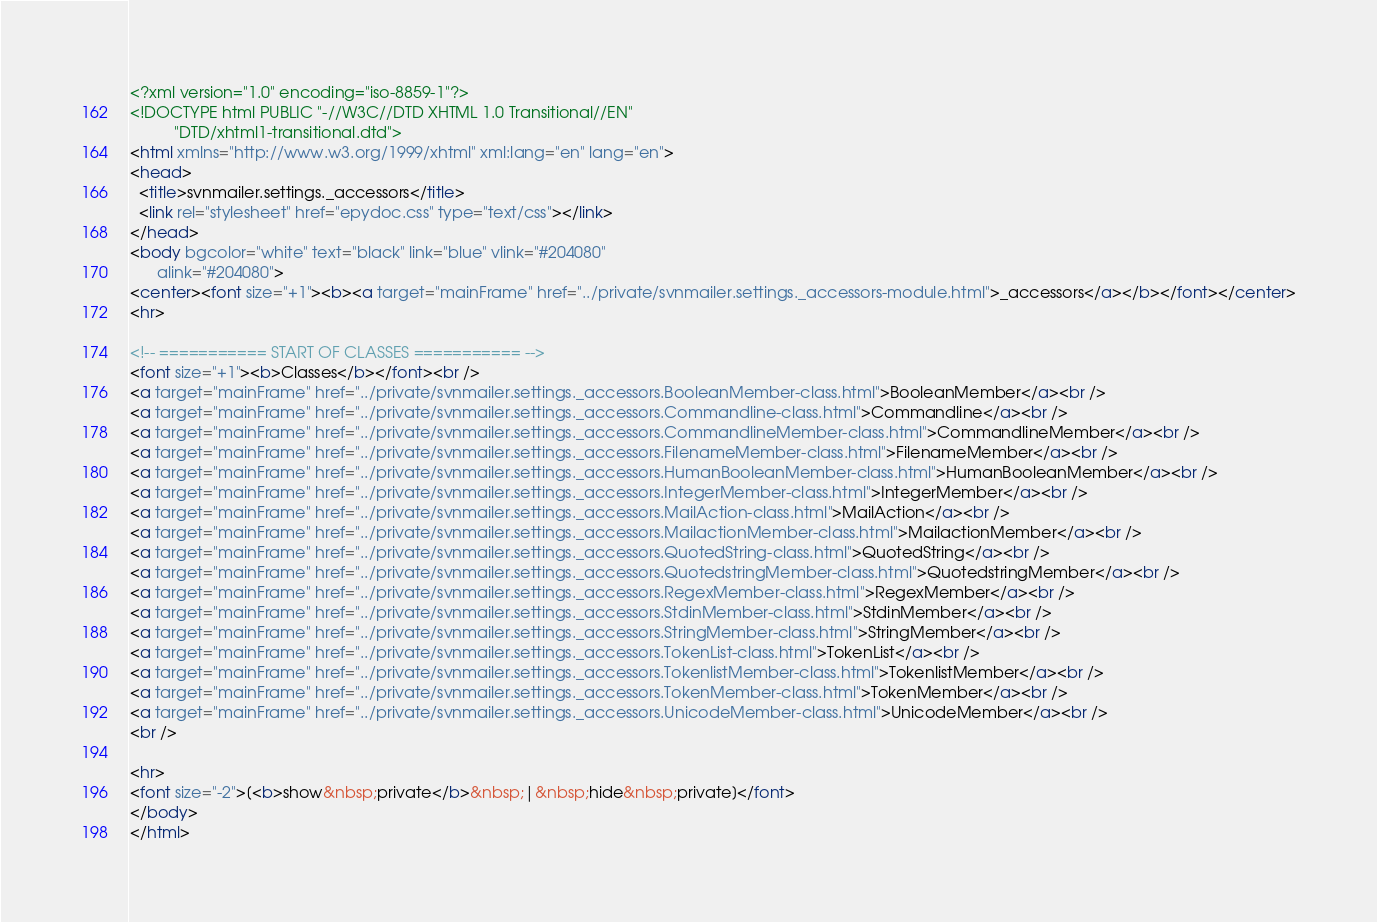Convert code to text. <code><loc_0><loc_0><loc_500><loc_500><_HTML_><?xml version="1.0" encoding="iso-8859-1"?>
<!DOCTYPE html PUBLIC "-//W3C//DTD XHTML 1.0 Transitional//EN"
          "DTD/xhtml1-transitional.dtd">
<html xmlns="http://www.w3.org/1999/xhtml" xml:lang="en" lang="en">
<head>
  <title>svnmailer.settings._accessors</title>
  <link rel="stylesheet" href="epydoc.css" type="text/css"></link>
</head>
<body bgcolor="white" text="black" link="blue" vlink="#204080"
      alink="#204080">
<center><font size="+1"><b><a target="mainFrame" href="../private/svnmailer.settings._accessors-module.html">_accessors</a></b></font></center>
<hr>

<!-- =========== START OF CLASSES =========== -->
<font size="+1"><b>Classes</b></font><br />
<a target="mainFrame" href="../private/svnmailer.settings._accessors.BooleanMember-class.html">BooleanMember</a><br />
<a target="mainFrame" href="../private/svnmailer.settings._accessors.Commandline-class.html">Commandline</a><br />
<a target="mainFrame" href="../private/svnmailer.settings._accessors.CommandlineMember-class.html">CommandlineMember</a><br />
<a target="mainFrame" href="../private/svnmailer.settings._accessors.FilenameMember-class.html">FilenameMember</a><br />
<a target="mainFrame" href="../private/svnmailer.settings._accessors.HumanBooleanMember-class.html">HumanBooleanMember</a><br />
<a target="mainFrame" href="../private/svnmailer.settings._accessors.IntegerMember-class.html">IntegerMember</a><br />
<a target="mainFrame" href="../private/svnmailer.settings._accessors.MailAction-class.html">MailAction</a><br />
<a target="mainFrame" href="../private/svnmailer.settings._accessors.MailactionMember-class.html">MailactionMember</a><br />
<a target="mainFrame" href="../private/svnmailer.settings._accessors.QuotedString-class.html">QuotedString</a><br />
<a target="mainFrame" href="../private/svnmailer.settings._accessors.QuotedstringMember-class.html">QuotedstringMember</a><br />
<a target="mainFrame" href="../private/svnmailer.settings._accessors.RegexMember-class.html">RegexMember</a><br />
<a target="mainFrame" href="../private/svnmailer.settings._accessors.StdinMember-class.html">StdinMember</a><br />
<a target="mainFrame" href="../private/svnmailer.settings._accessors.StringMember-class.html">StringMember</a><br />
<a target="mainFrame" href="../private/svnmailer.settings._accessors.TokenList-class.html">TokenList</a><br />
<a target="mainFrame" href="../private/svnmailer.settings._accessors.TokenlistMember-class.html">TokenlistMember</a><br />
<a target="mainFrame" href="../private/svnmailer.settings._accessors.TokenMember-class.html">TokenMember</a><br />
<a target="mainFrame" href="../private/svnmailer.settings._accessors.UnicodeMember-class.html">UnicodeMember</a><br />
<br />

<hr>
<font size="-2">[<b>show&nbsp;private</b>&nbsp;|&nbsp;hide&nbsp;private]</font>
</body>
</html>
</code> 